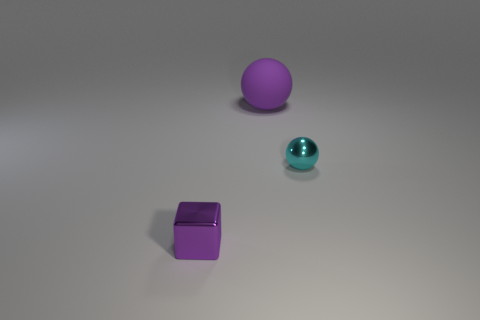Add 1 cyan spheres. How many objects exist? 4 Subtract all balls. How many objects are left? 1 Subtract 0 red blocks. How many objects are left? 3 Subtract all cyan objects. Subtract all cyan shiny things. How many objects are left? 1 Add 3 tiny objects. How many tiny objects are left? 5 Add 3 cyan metallic objects. How many cyan metallic objects exist? 4 